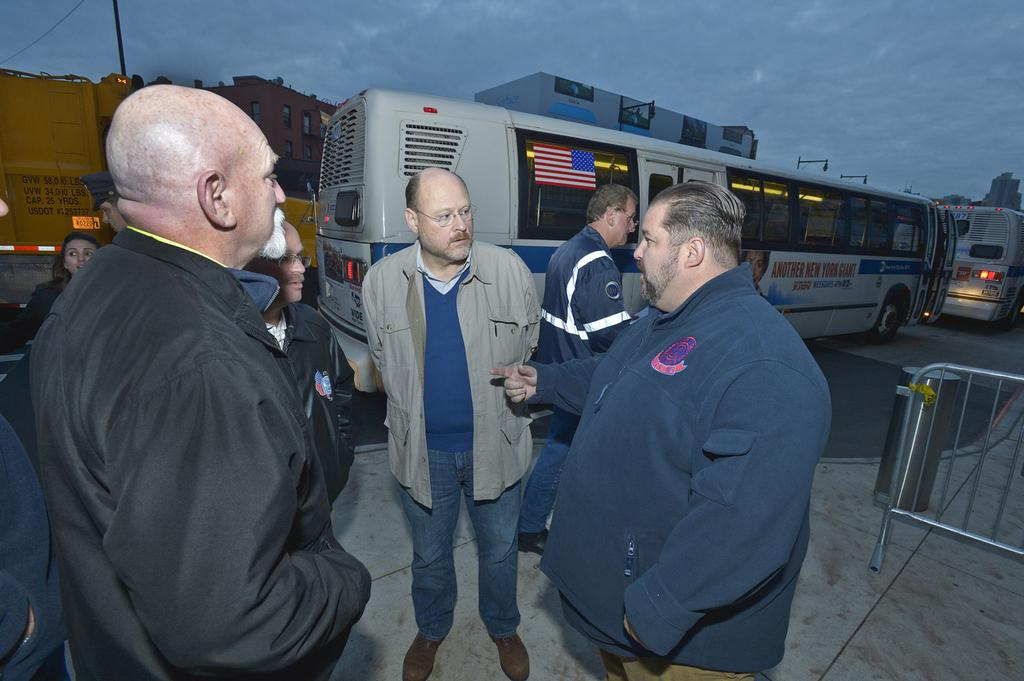How many people are in the image? There is a group of people in the image, but the exact number is not specified. What are the people doing in the image? The people are standing in the image. What can be seen beside the people? There are metal rods beside the people. What type of vehicles can be seen on the road in the image? There are buses on the road in the image. What is visible in the background of the image? There is a pole and a building in the background of the image. What does the wind taste like in the image? There is no mention of wind in the image, and therefore it cannot be tasted. 